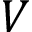Convert formula to latex. <formula><loc_0><loc_0><loc_500><loc_500>V</formula> 